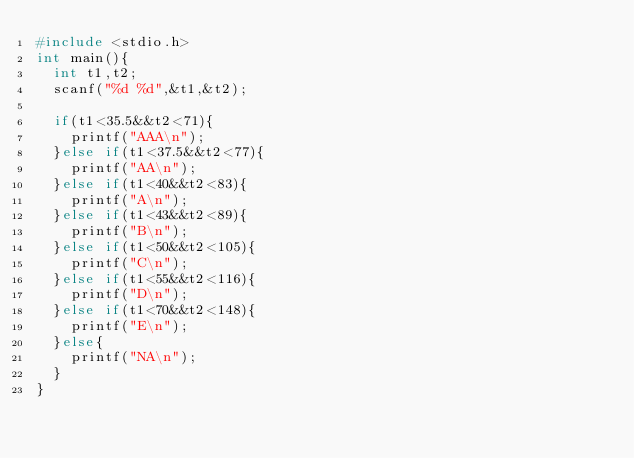Convert code to text. <code><loc_0><loc_0><loc_500><loc_500><_C++_>#include <stdio.h>
int main(){
  int t1,t2;
  scanf("%d %d",&t1,&t2);

  if(t1<35.5&&t2<71){
    printf("AAA\n");   
  }else if(t1<37.5&&t2<77){
    printf("AA\n");
  }else if(t1<40&&t2<83){
    printf("A\n");
  }else if(t1<43&&t2<89){
    printf("B\n");
  }else if(t1<50&&t2<105){
    printf("C\n");
  }else if(t1<55&&t2<116){
    printf("D\n");
  }else if(t1<70&&t2<148){
    printf("E\n");
  }else{
    printf("NA\n");   
  }
}
  
  </code> 